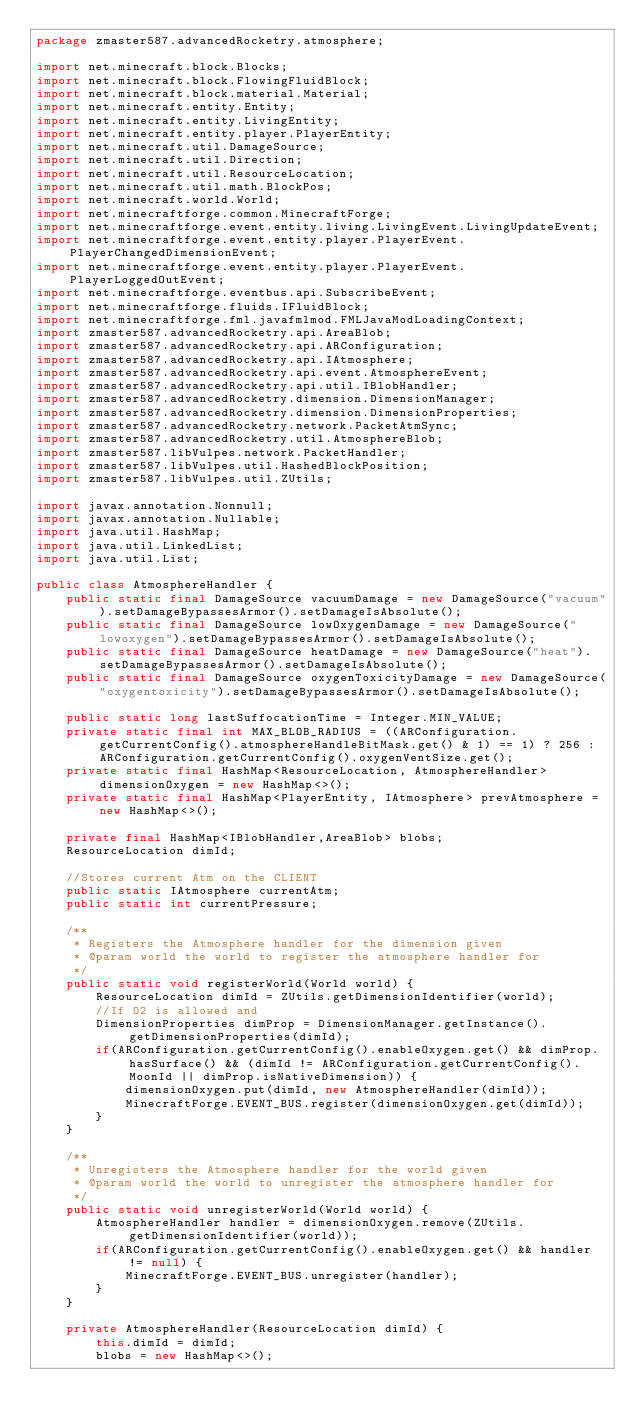<code> <loc_0><loc_0><loc_500><loc_500><_Java_>package zmaster587.advancedRocketry.atmosphere;

import net.minecraft.block.Blocks;
import net.minecraft.block.FlowingFluidBlock;
import net.minecraft.block.material.Material;
import net.minecraft.entity.Entity;
import net.minecraft.entity.LivingEntity;
import net.minecraft.entity.player.PlayerEntity;
import net.minecraft.util.DamageSource;
import net.minecraft.util.Direction;
import net.minecraft.util.ResourceLocation;
import net.minecraft.util.math.BlockPos;
import net.minecraft.world.World;
import net.minecraftforge.common.MinecraftForge;
import net.minecraftforge.event.entity.living.LivingEvent.LivingUpdateEvent;
import net.minecraftforge.event.entity.player.PlayerEvent.PlayerChangedDimensionEvent;
import net.minecraftforge.event.entity.player.PlayerEvent.PlayerLoggedOutEvent;
import net.minecraftforge.eventbus.api.SubscribeEvent;
import net.minecraftforge.fluids.IFluidBlock;
import net.minecraftforge.fml.javafmlmod.FMLJavaModLoadingContext;
import zmaster587.advancedRocketry.api.AreaBlob;
import zmaster587.advancedRocketry.api.ARConfiguration;
import zmaster587.advancedRocketry.api.IAtmosphere;
import zmaster587.advancedRocketry.api.event.AtmosphereEvent;
import zmaster587.advancedRocketry.api.util.IBlobHandler;
import zmaster587.advancedRocketry.dimension.DimensionManager;
import zmaster587.advancedRocketry.dimension.DimensionProperties;
import zmaster587.advancedRocketry.network.PacketAtmSync;
import zmaster587.advancedRocketry.util.AtmosphereBlob;
import zmaster587.libVulpes.network.PacketHandler;
import zmaster587.libVulpes.util.HashedBlockPosition;
import zmaster587.libVulpes.util.ZUtils;

import javax.annotation.Nonnull;
import javax.annotation.Nullable;
import java.util.HashMap;
import java.util.LinkedList;
import java.util.List;

public class AtmosphereHandler {
	public static final DamageSource vacuumDamage = new DamageSource("vacuum").setDamageBypassesArmor().setDamageIsAbsolute();
	public static final DamageSource lowOxygenDamage = new DamageSource("lowoxygen").setDamageBypassesArmor().setDamageIsAbsolute();
	public static final DamageSource heatDamage = new DamageSource("heat").setDamageBypassesArmor().setDamageIsAbsolute();
	public static final DamageSource oxygenToxicityDamage = new DamageSource("oxygentoxicity").setDamageBypassesArmor().setDamageIsAbsolute();

	public static long lastSuffocationTime = Integer.MIN_VALUE;
	private static final int MAX_BLOB_RADIUS = ((ARConfiguration.getCurrentConfig().atmosphereHandleBitMask.get() & 1) == 1) ? 256 : ARConfiguration.getCurrentConfig().oxygenVentSize.get();
	private static final HashMap<ResourceLocation, AtmosphereHandler> dimensionOxygen = new HashMap<>();
	private static final HashMap<PlayerEntity, IAtmosphere> prevAtmosphere = new HashMap<>();

	private final HashMap<IBlobHandler,AreaBlob> blobs;
	ResourceLocation dimId;

	//Stores current Atm on the CLIENT
	public static IAtmosphere currentAtm;
	public static int currentPressure;

	/**
	 * Registers the Atmosphere handler for the dimension given
	 * @param world the world to register the atmosphere handler for
	 */
	public static void registerWorld(World world) {
		ResourceLocation dimId = ZUtils.getDimensionIdentifier(world);
		//If O2 is allowed and
		DimensionProperties dimProp = DimensionManager.getInstance().getDimensionProperties(dimId);
		if(ARConfiguration.getCurrentConfig().enableOxygen.get() && dimProp.hasSurface() && (dimId != ARConfiguration.getCurrentConfig().MoonId || dimProp.isNativeDimension)) {
			dimensionOxygen.put(dimId, new AtmosphereHandler(dimId));
			MinecraftForge.EVENT_BUS.register(dimensionOxygen.get(dimId));
		}
	}

	/**
	 * Unregisters the Atmosphere handler for the world given
	 * @param world the world to unregister the atmosphere handler for
	 */
	public static void unregisterWorld(World world) {
		AtmosphereHandler handler = dimensionOxygen.remove(ZUtils.getDimensionIdentifier(world));
		if(ARConfiguration.getCurrentConfig().enableOxygen.get() && handler != null) {
			MinecraftForge.EVENT_BUS.unregister(handler);
		}
	}

	private AtmosphereHandler(ResourceLocation dimId) {
		this.dimId = dimId;
		blobs = new HashMap<>();</code> 